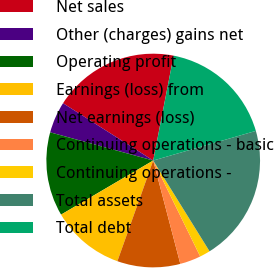<chart> <loc_0><loc_0><loc_500><loc_500><pie_chart><fcel>Net sales<fcel>Other (charges) gains net<fcel>Operating profit<fcel>Earnings (loss) from<fcel>Net earnings (loss)<fcel>Continuing operations - basic<fcel>Continuing operations -<fcel>Total assets<fcel>Total debt<nl><fcel>19.05%<fcel>4.76%<fcel>12.7%<fcel>11.11%<fcel>9.52%<fcel>3.17%<fcel>1.59%<fcel>20.63%<fcel>17.46%<nl></chart> 